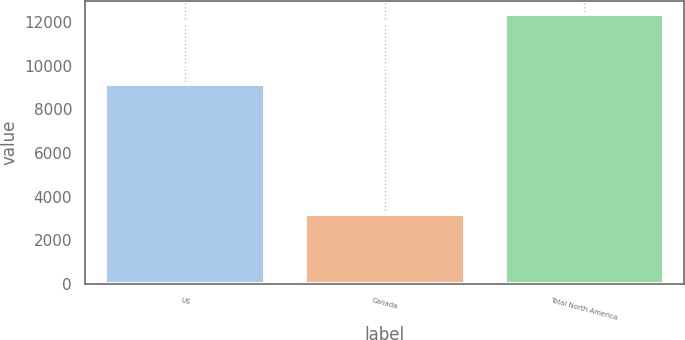<chart> <loc_0><loc_0><loc_500><loc_500><bar_chart><fcel>US<fcel>Canada<fcel>Total North America<nl><fcel>9165<fcel>3195<fcel>12360<nl></chart> 